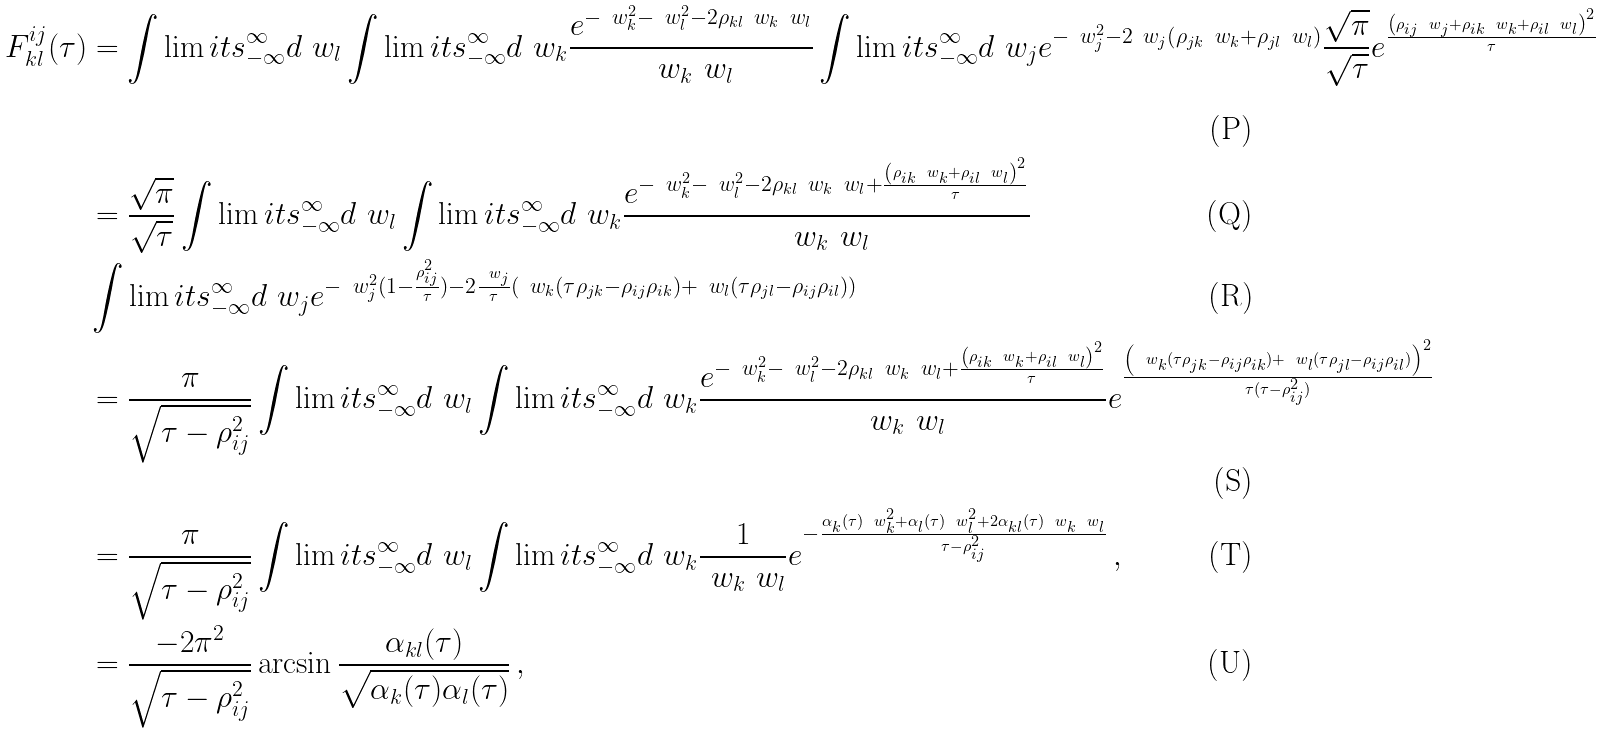Convert formula to latex. <formula><loc_0><loc_0><loc_500><loc_500>F _ { k l } ^ { i j } ( \tau ) & = \int \lim i t s _ { - \infty } ^ { \infty } d \ w _ { l } \int \lim i t s _ { - \infty } ^ { \infty } d \ w _ { k } \frac { e ^ { - \ w _ { k } ^ { 2 } - \ w _ { l } ^ { 2 } - 2 \rho _ { k l } \ w _ { k } \ w _ { l } } } { \ w _ { k } \ w _ { l } } \int \lim i t s _ { - \infty } ^ { \infty } d \ w _ { j } e ^ { - \ w _ { j } ^ { 2 } - 2 \ w _ { j } \left ( \rho _ { j k } \ w _ { k } + \rho _ { j l } \ w _ { l } \right ) } \frac { \sqrt { \pi } } { \sqrt { \tau } } e ^ { \frac { \left ( \rho _ { i j } \ w _ { j } + \rho _ { i k } \ w _ { k } + \rho _ { i l } \ w _ { l } \right ) ^ { 2 } } { \tau } } \\ & = \frac { \sqrt { \pi } } { \sqrt { \tau } } \int \lim i t s _ { - \infty } ^ { \infty } d \ w _ { l } \int \lim i t s _ { - \infty } ^ { \infty } d \ w _ { k } \frac { e ^ { - \ w _ { k } ^ { 2 } - \ w _ { l } ^ { 2 } - 2 \rho _ { k l } \ w _ { k } \ w _ { l } + \frac { \left ( \rho _ { i k } \ w _ { k } + \rho _ { i l } \ w _ { l } \right ) ^ { 2 } } { \tau } } } { \ w _ { k } \ w _ { l } } \, \\ & \int \lim i t s _ { - \infty } ^ { \infty } d \ w _ { j } e ^ { - \ w _ { j } ^ { 2 } ( 1 - \frac { \rho _ { i j } ^ { 2 } } { \tau } ) - 2 \frac { \ w _ { j } } { \tau } \left ( \ w _ { k } ( \tau \rho _ { j k } - \rho _ { i j } \rho _ { i k } ) + \ w _ { l } ( \tau \rho _ { j l } - \rho _ { i j } \rho _ { i l } ) \right ) } \\ & = \frac { \pi } { \sqrt { \tau - \rho _ { i j } ^ { 2 } } } \int \lim i t s _ { - \infty } ^ { \infty } d \ w _ { l } \int \lim i t s _ { - \infty } ^ { \infty } d \ w _ { k } \frac { e ^ { - \ w _ { k } ^ { 2 } - \ w _ { l } ^ { 2 } - 2 \rho _ { k l } \ w _ { k } \ w _ { l } + \frac { \left ( \rho _ { i k } \ w _ { k } + \rho _ { i l } \ w _ { l } \right ) ^ { 2 } } { \tau } } } { \ w _ { k } \ w _ { l } } e ^ { \frac { \left ( \ w _ { k } ( \tau \rho _ { j k } - \rho _ { i j } \rho _ { i k } ) + \ w _ { l } ( \tau \rho _ { j l } - \rho _ { i j } \rho _ { i l } ) \right ) ^ { 2 } } { \tau ( \tau - \rho _ { i j } ^ { 2 } ) } } \\ & = \frac { \pi } { \sqrt { \tau - \rho _ { i j } ^ { 2 } } } \int \lim i t s _ { - \infty } ^ { \infty } d \ w _ { l } \int \lim i t s _ { - \infty } ^ { \infty } d \ w _ { k } \frac { 1 } { \ w _ { k } \ w _ { l } } e ^ { - \frac { \alpha _ { k } ( \tau ) \ w _ { k } ^ { 2 } + \alpha _ { l } ( \tau ) \ w _ { l } ^ { 2 } + 2 \alpha _ { k l } ( \tau ) \ w _ { k } \ w _ { l } } { \tau - \rho _ { i j } ^ { 2 } } } \, , \\ & = \frac { - 2 \pi ^ { 2 } } { \sqrt { \tau - \rho _ { i j } ^ { 2 } } } \arcsin { \frac { \alpha _ { k l } ( \tau ) } { \sqrt { \alpha _ { k } ( \tau ) \alpha _ { l } ( \tau ) } } } \, ,</formula> 